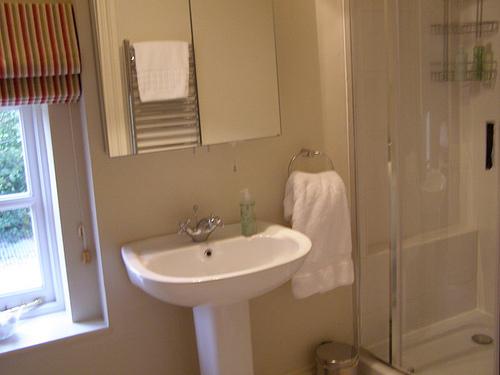What season is this photo taken in?
Be succinct. Spring. What side is the soap on?
Short answer required. Right. Is the towel fresh or used?
Keep it brief. Fresh. 